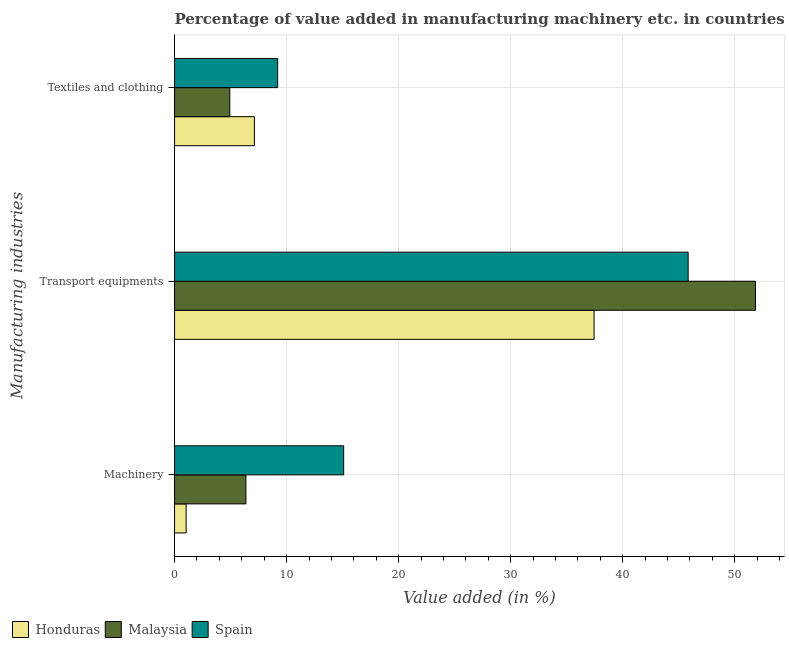How many different coloured bars are there?
Ensure brevity in your answer.  3. How many groups of bars are there?
Offer a terse response. 3. Are the number of bars per tick equal to the number of legend labels?
Offer a terse response. Yes. Are the number of bars on each tick of the Y-axis equal?
Make the answer very short. Yes. What is the label of the 3rd group of bars from the top?
Offer a terse response. Machinery. What is the value added in manufacturing textile and clothing in Honduras?
Provide a succinct answer. 7.12. Across all countries, what is the maximum value added in manufacturing transport equipments?
Provide a succinct answer. 51.84. Across all countries, what is the minimum value added in manufacturing transport equipments?
Your response must be concise. 37.44. In which country was the value added in manufacturing textile and clothing maximum?
Your answer should be very brief. Spain. In which country was the value added in manufacturing textile and clothing minimum?
Ensure brevity in your answer.  Malaysia. What is the total value added in manufacturing transport equipments in the graph?
Ensure brevity in your answer.  135.12. What is the difference between the value added in manufacturing machinery in Malaysia and that in Spain?
Provide a succinct answer. -8.72. What is the difference between the value added in manufacturing transport equipments in Malaysia and the value added in manufacturing textile and clothing in Honduras?
Give a very brief answer. 44.72. What is the average value added in manufacturing textile and clothing per country?
Give a very brief answer. 7.09. What is the difference between the value added in manufacturing transport equipments and value added in manufacturing machinery in Malaysia?
Give a very brief answer. 45.47. In how many countries, is the value added in manufacturing textile and clothing greater than 40 %?
Provide a short and direct response. 0. What is the ratio of the value added in manufacturing textile and clothing in Spain to that in Honduras?
Provide a succinct answer. 1.29. Is the value added in manufacturing machinery in Spain less than that in Honduras?
Your answer should be very brief. No. Is the difference between the value added in manufacturing textile and clothing in Malaysia and Honduras greater than the difference between the value added in manufacturing transport equipments in Malaysia and Honduras?
Your answer should be compact. No. What is the difference between the highest and the second highest value added in manufacturing machinery?
Your response must be concise. 8.72. What is the difference between the highest and the lowest value added in manufacturing textile and clothing?
Offer a terse response. 4.27. In how many countries, is the value added in manufacturing transport equipments greater than the average value added in manufacturing transport equipments taken over all countries?
Your answer should be very brief. 2. What does the 2nd bar from the top in Machinery represents?
Your response must be concise. Malaysia. What does the 1st bar from the bottom in Transport equipments represents?
Provide a short and direct response. Honduras. Is it the case that in every country, the sum of the value added in manufacturing machinery and value added in manufacturing transport equipments is greater than the value added in manufacturing textile and clothing?
Your response must be concise. Yes. What is the difference between two consecutive major ticks on the X-axis?
Your response must be concise. 10. Are the values on the major ticks of X-axis written in scientific E-notation?
Make the answer very short. No. Does the graph contain any zero values?
Your answer should be very brief. No. Does the graph contain grids?
Your answer should be compact. Yes. Where does the legend appear in the graph?
Offer a very short reply. Bottom left. How many legend labels are there?
Keep it short and to the point. 3. What is the title of the graph?
Your answer should be compact. Percentage of value added in manufacturing machinery etc. in countries. What is the label or title of the X-axis?
Offer a terse response. Value added (in %). What is the label or title of the Y-axis?
Give a very brief answer. Manufacturing industries. What is the Value added (in %) in Honduras in Machinery?
Give a very brief answer. 1.03. What is the Value added (in %) of Malaysia in Machinery?
Offer a very short reply. 6.37. What is the Value added (in %) of Spain in Machinery?
Keep it short and to the point. 15.09. What is the Value added (in %) of Honduras in Transport equipments?
Offer a very short reply. 37.44. What is the Value added (in %) of Malaysia in Transport equipments?
Provide a short and direct response. 51.84. What is the Value added (in %) in Spain in Transport equipments?
Your answer should be compact. 45.83. What is the Value added (in %) of Honduras in Textiles and clothing?
Provide a short and direct response. 7.12. What is the Value added (in %) of Malaysia in Textiles and clothing?
Provide a short and direct response. 4.93. What is the Value added (in %) in Spain in Textiles and clothing?
Your answer should be compact. 9.2. Across all Manufacturing industries, what is the maximum Value added (in %) in Honduras?
Ensure brevity in your answer.  37.44. Across all Manufacturing industries, what is the maximum Value added (in %) in Malaysia?
Your answer should be compact. 51.84. Across all Manufacturing industries, what is the maximum Value added (in %) of Spain?
Keep it short and to the point. 45.83. Across all Manufacturing industries, what is the minimum Value added (in %) in Honduras?
Give a very brief answer. 1.03. Across all Manufacturing industries, what is the minimum Value added (in %) in Malaysia?
Give a very brief answer. 4.93. Across all Manufacturing industries, what is the minimum Value added (in %) of Spain?
Ensure brevity in your answer.  9.2. What is the total Value added (in %) in Honduras in the graph?
Your response must be concise. 45.6. What is the total Value added (in %) of Malaysia in the graph?
Your answer should be compact. 63.14. What is the total Value added (in %) of Spain in the graph?
Your response must be concise. 70.13. What is the difference between the Value added (in %) in Honduras in Machinery and that in Transport equipments?
Make the answer very short. -36.41. What is the difference between the Value added (in %) of Malaysia in Machinery and that in Transport equipments?
Your answer should be very brief. -45.47. What is the difference between the Value added (in %) in Spain in Machinery and that in Transport equipments?
Your answer should be compact. -30.74. What is the difference between the Value added (in %) of Honduras in Machinery and that in Textiles and clothing?
Keep it short and to the point. -6.09. What is the difference between the Value added (in %) in Malaysia in Machinery and that in Textiles and clothing?
Ensure brevity in your answer.  1.44. What is the difference between the Value added (in %) of Spain in Machinery and that in Textiles and clothing?
Provide a short and direct response. 5.89. What is the difference between the Value added (in %) of Honduras in Transport equipments and that in Textiles and clothing?
Provide a short and direct response. 30.32. What is the difference between the Value added (in %) in Malaysia in Transport equipments and that in Textiles and clothing?
Keep it short and to the point. 46.91. What is the difference between the Value added (in %) in Spain in Transport equipments and that in Textiles and clothing?
Provide a short and direct response. 36.63. What is the difference between the Value added (in %) of Honduras in Machinery and the Value added (in %) of Malaysia in Transport equipments?
Ensure brevity in your answer.  -50.81. What is the difference between the Value added (in %) of Honduras in Machinery and the Value added (in %) of Spain in Transport equipments?
Give a very brief answer. -44.8. What is the difference between the Value added (in %) in Malaysia in Machinery and the Value added (in %) in Spain in Transport equipments?
Your answer should be compact. -39.47. What is the difference between the Value added (in %) of Honduras in Machinery and the Value added (in %) of Malaysia in Textiles and clothing?
Your answer should be very brief. -3.9. What is the difference between the Value added (in %) in Honduras in Machinery and the Value added (in %) in Spain in Textiles and clothing?
Make the answer very short. -8.17. What is the difference between the Value added (in %) of Malaysia in Machinery and the Value added (in %) of Spain in Textiles and clothing?
Provide a short and direct response. -2.83. What is the difference between the Value added (in %) in Honduras in Transport equipments and the Value added (in %) in Malaysia in Textiles and clothing?
Your answer should be very brief. 32.51. What is the difference between the Value added (in %) in Honduras in Transport equipments and the Value added (in %) in Spain in Textiles and clothing?
Offer a very short reply. 28.24. What is the difference between the Value added (in %) of Malaysia in Transport equipments and the Value added (in %) of Spain in Textiles and clothing?
Provide a succinct answer. 42.64. What is the average Value added (in %) of Honduras per Manufacturing industries?
Offer a very short reply. 15.2. What is the average Value added (in %) of Malaysia per Manufacturing industries?
Ensure brevity in your answer.  21.05. What is the average Value added (in %) in Spain per Manufacturing industries?
Your response must be concise. 23.38. What is the difference between the Value added (in %) of Honduras and Value added (in %) of Malaysia in Machinery?
Your answer should be compact. -5.34. What is the difference between the Value added (in %) of Honduras and Value added (in %) of Spain in Machinery?
Offer a terse response. -14.06. What is the difference between the Value added (in %) of Malaysia and Value added (in %) of Spain in Machinery?
Your answer should be very brief. -8.72. What is the difference between the Value added (in %) in Honduras and Value added (in %) in Malaysia in Transport equipments?
Offer a very short reply. -14.4. What is the difference between the Value added (in %) of Honduras and Value added (in %) of Spain in Transport equipments?
Offer a very short reply. -8.39. What is the difference between the Value added (in %) of Malaysia and Value added (in %) of Spain in Transport equipments?
Your answer should be compact. 6.01. What is the difference between the Value added (in %) in Honduras and Value added (in %) in Malaysia in Textiles and clothing?
Ensure brevity in your answer.  2.19. What is the difference between the Value added (in %) of Honduras and Value added (in %) of Spain in Textiles and clothing?
Your answer should be compact. -2.07. What is the difference between the Value added (in %) of Malaysia and Value added (in %) of Spain in Textiles and clothing?
Offer a very short reply. -4.27. What is the ratio of the Value added (in %) in Honduras in Machinery to that in Transport equipments?
Keep it short and to the point. 0.03. What is the ratio of the Value added (in %) in Malaysia in Machinery to that in Transport equipments?
Provide a succinct answer. 0.12. What is the ratio of the Value added (in %) in Spain in Machinery to that in Transport equipments?
Give a very brief answer. 0.33. What is the ratio of the Value added (in %) of Honduras in Machinery to that in Textiles and clothing?
Your response must be concise. 0.14. What is the ratio of the Value added (in %) in Malaysia in Machinery to that in Textiles and clothing?
Your response must be concise. 1.29. What is the ratio of the Value added (in %) in Spain in Machinery to that in Textiles and clothing?
Offer a terse response. 1.64. What is the ratio of the Value added (in %) of Honduras in Transport equipments to that in Textiles and clothing?
Offer a very short reply. 5.25. What is the ratio of the Value added (in %) in Malaysia in Transport equipments to that in Textiles and clothing?
Your answer should be compact. 10.51. What is the ratio of the Value added (in %) in Spain in Transport equipments to that in Textiles and clothing?
Make the answer very short. 4.98. What is the difference between the highest and the second highest Value added (in %) in Honduras?
Your answer should be very brief. 30.32. What is the difference between the highest and the second highest Value added (in %) in Malaysia?
Give a very brief answer. 45.47. What is the difference between the highest and the second highest Value added (in %) in Spain?
Your answer should be very brief. 30.74. What is the difference between the highest and the lowest Value added (in %) of Honduras?
Your response must be concise. 36.41. What is the difference between the highest and the lowest Value added (in %) of Malaysia?
Your response must be concise. 46.91. What is the difference between the highest and the lowest Value added (in %) in Spain?
Provide a short and direct response. 36.63. 